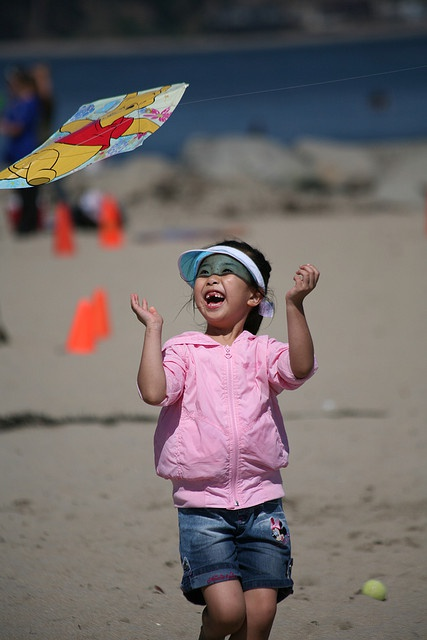Describe the objects in this image and their specific colors. I can see people in black, pink, brown, and gray tones, kite in black, darkgray, tan, brown, and olive tones, people in black, navy, maroon, and purple tones, people in black and maroon tones, and sports ball in black, olive, and darkgreen tones in this image. 